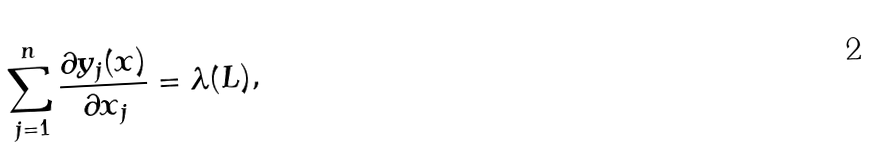Convert formula to latex. <formula><loc_0><loc_0><loc_500><loc_500>\sum _ { j = 1 } ^ { n } \frac { \partial y _ { j } ( x ) } { \partial x _ { j } } = \lambda ( L ) ,</formula> 